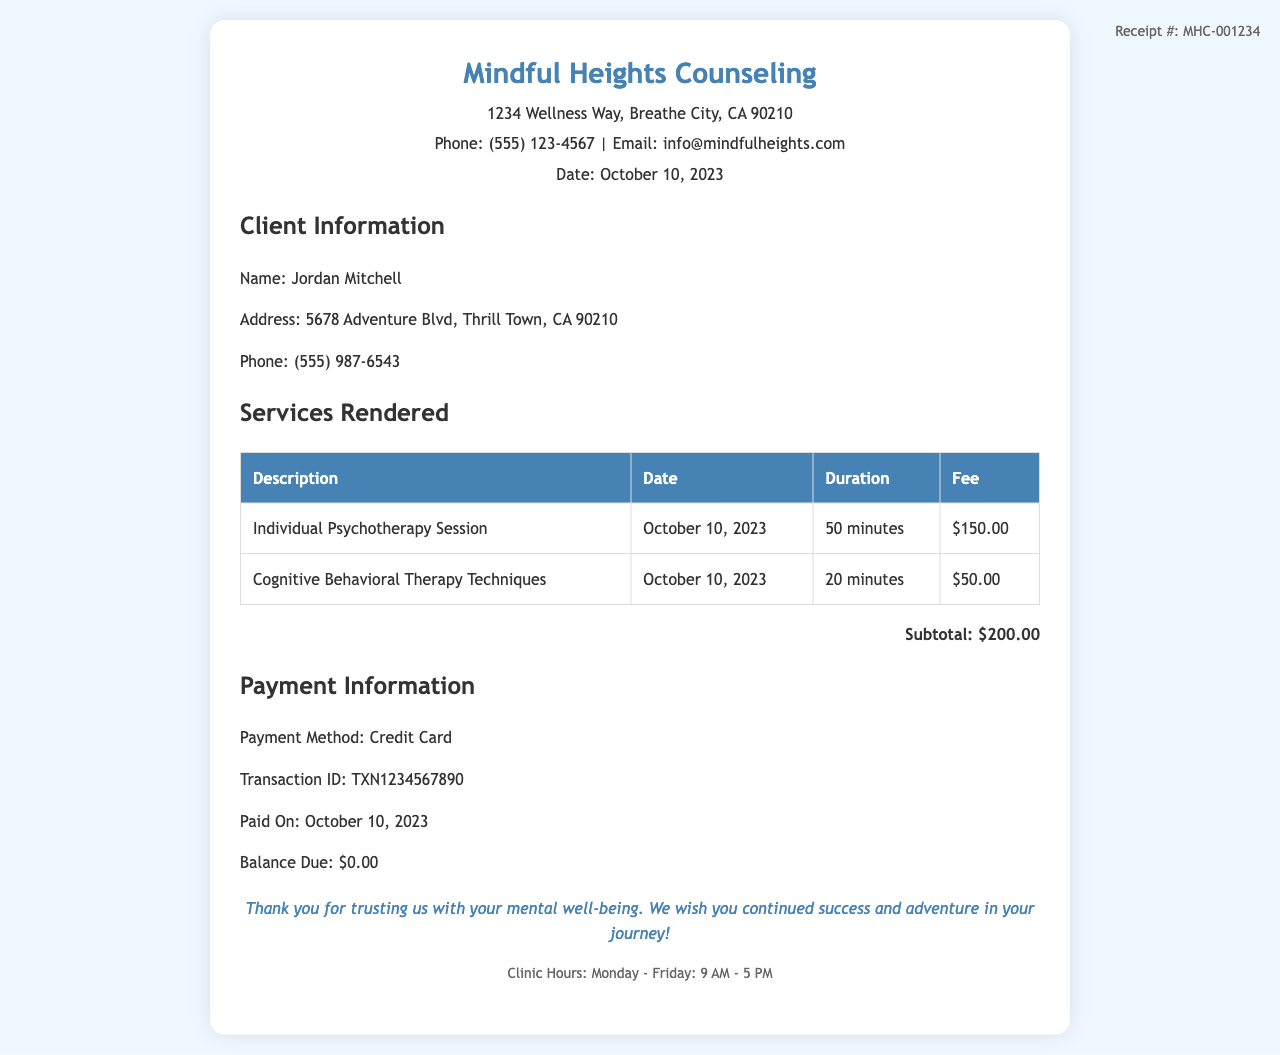What is the name of the clinic? The name of the clinic is provided in the header section of the receipt.
Answer: Mindful Heights Counseling Who is the client? The client's name is stated in the "Client Information" section of the receipt.
Answer: Jordan Mitchell What was the date of the session? The date of the session is mentioned in both the header and the services rendered sections of the receipt.
Answer: October 10, 2023 What is the total fee for services rendered? The total fee is shown in the services section as the subtotal.
Answer: $200.00 What amount was paid? The paid amount is listed in the payment information section under "Paid On."
Answer: $200.00 What is the payment method used? The method of payment is stated in the payment information section.
Answer: Credit Card What is the transaction ID? The transaction ID is given in the payment information section as a unique identifier for the payment.
Answer: TXN1234567890 What duration was the individual psychotherapy session? The duration of the individual psychotherapy session is specified in the services rendered table.
Answer: 50 minutes What is the balance due? The amount listed under "Balance Due" in the payment information section indicates what remains to be paid.
Answer: $0.00 